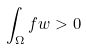Convert formula to latex. <formula><loc_0><loc_0><loc_500><loc_500>\int _ { \Omega } f w > 0</formula> 